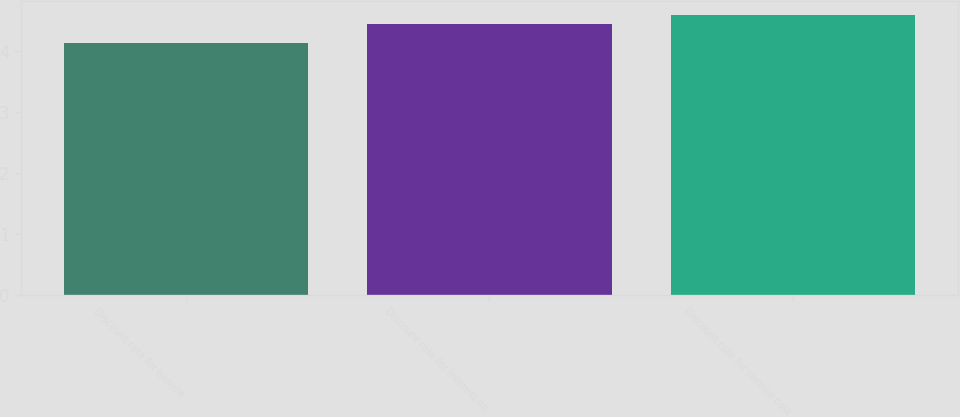Convert chart to OTSL. <chart><loc_0><loc_0><loc_500><loc_500><bar_chart><fcel>Discount rate for benefit<fcel>Discount rate for interest on<fcel>Discount rate for service cost<nl><fcel>4.13<fcel>4.44<fcel>4.59<nl></chart> 